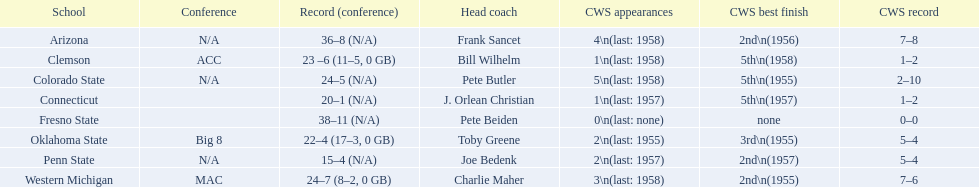What are the names of all the schools? Arizona, Clemson, Colorado State, Connecticut, Fresno State, Oklahoma State, Penn State, Western Michigan. What is each school's record? 36–8 (N/A), 23 –6 (11–5, 0 GB), 24–5 (N/A), 20–1 (N/A), 38–11 (N/A), 22–4 (17–3, 0 GB), 15–4 (N/A), 24–7 (8–2, 0 GB). Which school has the lowest number of victories? Penn State. 